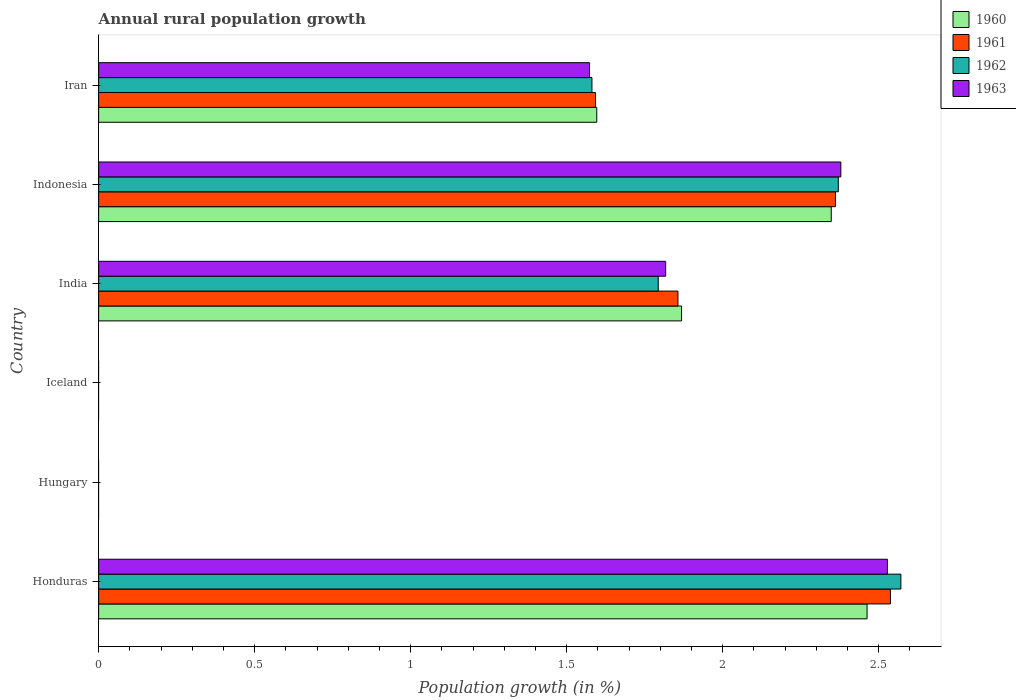Are the number of bars on each tick of the Y-axis equal?
Offer a very short reply. No. How many bars are there on the 6th tick from the bottom?
Make the answer very short. 4. What is the label of the 1st group of bars from the top?
Ensure brevity in your answer.  Iran. In how many cases, is the number of bars for a given country not equal to the number of legend labels?
Your answer should be compact. 2. What is the percentage of rural population growth in 1963 in Honduras?
Ensure brevity in your answer.  2.53. Across all countries, what is the maximum percentage of rural population growth in 1961?
Give a very brief answer. 2.54. In which country was the percentage of rural population growth in 1963 maximum?
Provide a succinct answer. Honduras. What is the total percentage of rural population growth in 1960 in the graph?
Provide a succinct answer. 8.28. What is the difference between the percentage of rural population growth in 1960 in Indonesia and that in Iran?
Provide a short and direct response. 0.75. What is the difference between the percentage of rural population growth in 1960 in India and the percentage of rural population growth in 1961 in Iran?
Provide a succinct answer. 0.28. What is the average percentage of rural population growth in 1963 per country?
Keep it short and to the point. 1.38. What is the difference between the percentage of rural population growth in 1961 and percentage of rural population growth in 1963 in Honduras?
Make the answer very short. 0.01. In how many countries, is the percentage of rural population growth in 1963 greater than 1.5 %?
Your response must be concise. 4. What is the ratio of the percentage of rural population growth in 1960 in Honduras to that in India?
Offer a terse response. 1.32. What is the difference between the highest and the second highest percentage of rural population growth in 1962?
Keep it short and to the point. 0.2. What is the difference between the highest and the lowest percentage of rural population growth in 1961?
Make the answer very short. 2.54. In how many countries, is the percentage of rural population growth in 1961 greater than the average percentage of rural population growth in 1961 taken over all countries?
Make the answer very short. 4. Is it the case that in every country, the sum of the percentage of rural population growth in 1962 and percentage of rural population growth in 1963 is greater than the sum of percentage of rural population growth in 1960 and percentage of rural population growth in 1961?
Ensure brevity in your answer.  No. Is it the case that in every country, the sum of the percentage of rural population growth in 1962 and percentage of rural population growth in 1960 is greater than the percentage of rural population growth in 1963?
Keep it short and to the point. No. How many countries are there in the graph?
Your response must be concise. 6. What is the difference between two consecutive major ticks on the X-axis?
Your answer should be very brief. 0.5. Does the graph contain any zero values?
Provide a succinct answer. Yes. Does the graph contain grids?
Provide a succinct answer. No. Where does the legend appear in the graph?
Give a very brief answer. Top right. How many legend labels are there?
Give a very brief answer. 4. What is the title of the graph?
Keep it short and to the point. Annual rural population growth. Does "1970" appear as one of the legend labels in the graph?
Provide a succinct answer. No. What is the label or title of the X-axis?
Your answer should be very brief. Population growth (in %). What is the label or title of the Y-axis?
Your response must be concise. Country. What is the Population growth (in %) in 1960 in Honduras?
Your response must be concise. 2.46. What is the Population growth (in %) of 1961 in Honduras?
Make the answer very short. 2.54. What is the Population growth (in %) of 1962 in Honduras?
Provide a succinct answer. 2.57. What is the Population growth (in %) of 1963 in Honduras?
Give a very brief answer. 2.53. What is the Population growth (in %) of 1961 in Hungary?
Offer a very short reply. 0. What is the Population growth (in %) of 1962 in Hungary?
Make the answer very short. 0. What is the Population growth (in %) of 1960 in Iceland?
Keep it short and to the point. 0. What is the Population growth (in %) in 1963 in Iceland?
Provide a succinct answer. 0. What is the Population growth (in %) in 1960 in India?
Your response must be concise. 1.87. What is the Population growth (in %) in 1961 in India?
Ensure brevity in your answer.  1.86. What is the Population growth (in %) in 1962 in India?
Offer a very short reply. 1.79. What is the Population growth (in %) in 1963 in India?
Keep it short and to the point. 1.82. What is the Population growth (in %) of 1960 in Indonesia?
Your answer should be very brief. 2.35. What is the Population growth (in %) of 1961 in Indonesia?
Make the answer very short. 2.36. What is the Population growth (in %) in 1962 in Indonesia?
Provide a short and direct response. 2.37. What is the Population growth (in %) of 1963 in Indonesia?
Your response must be concise. 2.38. What is the Population growth (in %) in 1960 in Iran?
Offer a very short reply. 1.6. What is the Population growth (in %) of 1961 in Iran?
Give a very brief answer. 1.59. What is the Population growth (in %) in 1962 in Iran?
Provide a short and direct response. 1.58. What is the Population growth (in %) of 1963 in Iran?
Provide a short and direct response. 1.57. Across all countries, what is the maximum Population growth (in %) in 1960?
Provide a succinct answer. 2.46. Across all countries, what is the maximum Population growth (in %) of 1961?
Make the answer very short. 2.54. Across all countries, what is the maximum Population growth (in %) of 1962?
Keep it short and to the point. 2.57. Across all countries, what is the maximum Population growth (in %) of 1963?
Offer a terse response. 2.53. Across all countries, what is the minimum Population growth (in %) of 1961?
Your answer should be very brief. 0. What is the total Population growth (in %) in 1960 in the graph?
Your answer should be compact. 8.28. What is the total Population growth (in %) in 1961 in the graph?
Offer a terse response. 8.35. What is the total Population growth (in %) of 1962 in the graph?
Keep it short and to the point. 8.32. What is the total Population growth (in %) of 1963 in the graph?
Make the answer very short. 8.3. What is the difference between the Population growth (in %) of 1960 in Honduras and that in India?
Provide a short and direct response. 0.59. What is the difference between the Population growth (in %) of 1961 in Honduras and that in India?
Your response must be concise. 0.68. What is the difference between the Population growth (in %) of 1962 in Honduras and that in India?
Provide a short and direct response. 0.78. What is the difference between the Population growth (in %) in 1963 in Honduras and that in India?
Offer a very short reply. 0.71. What is the difference between the Population growth (in %) in 1960 in Honduras and that in Indonesia?
Provide a succinct answer. 0.11. What is the difference between the Population growth (in %) of 1961 in Honduras and that in Indonesia?
Your response must be concise. 0.18. What is the difference between the Population growth (in %) in 1962 in Honduras and that in Indonesia?
Your answer should be compact. 0.2. What is the difference between the Population growth (in %) of 1963 in Honduras and that in Indonesia?
Provide a short and direct response. 0.15. What is the difference between the Population growth (in %) of 1960 in Honduras and that in Iran?
Provide a succinct answer. 0.87. What is the difference between the Population growth (in %) in 1961 in Honduras and that in Iran?
Give a very brief answer. 0.95. What is the difference between the Population growth (in %) of 1962 in Honduras and that in Iran?
Your answer should be compact. 0.99. What is the difference between the Population growth (in %) of 1963 in Honduras and that in Iran?
Keep it short and to the point. 0.95. What is the difference between the Population growth (in %) of 1960 in India and that in Indonesia?
Offer a terse response. -0.48. What is the difference between the Population growth (in %) of 1961 in India and that in Indonesia?
Your answer should be compact. -0.5. What is the difference between the Population growth (in %) of 1962 in India and that in Indonesia?
Provide a short and direct response. -0.58. What is the difference between the Population growth (in %) of 1963 in India and that in Indonesia?
Give a very brief answer. -0.56. What is the difference between the Population growth (in %) in 1960 in India and that in Iran?
Give a very brief answer. 0.27. What is the difference between the Population growth (in %) in 1961 in India and that in Iran?
Make the answer very short. 0.26. What is the difference between the Population growth (in %) in 1962 in India and that in Iran?
Provide a short and direct response. 0.21. What is the difference between the Population growth (in %) in 1963 in India and that in Iran?
Make the answer very short. 0.24. What is the difference between the Population growth (in %) of 1960 in Indonesia and that in Iran?
Your response must be concise. 0.75. What is the difference between the Population growth (in %) in 1961 in Indonesia and that in Iran?
Provide a short and direct response. 0.77. What is the difference between the Population growth (in %) in 1962 in Indonesia and that in Iran?
Offer a terse response. 0.79. What is the difference between the Population growth (in %) in 1963 in Indonesia and that in Iran?
Offer a very short reply. 0.81. What is the difference between the Population growth (in %) in 1960 in Honduras and the Population growth (in %) in 1961 in India?
Offer a very short reply. 0.61. What is the difference between the Population growth (in %) of 1960 in Honduras and the Population growth (in %) of 1962 in India?
Offer a very short reply. 0.67. What is the difference between the Population growth (in %) of 1960 in Honduras and the Population growth (in %) of 1963 in India?
Your answer should be very brief. 0.65. What is the difference between the Population growth (in %) of 1961 in Honduras and the Population growth (in %) of 1962 in India?
Keep it short and to the point. 0.74. What is the difference between the Population growth (in %) in 1961 in Honduras and the Population growth (in %) in 1963 in India?
Give a very brief answer. 0.72. What is the difference between the Population growth (in %) of 1962 in Honduras and the Population growth (in %) of 1963 in India?
Provide a short and direct response. 0.75. What is the difference between the Population growth (in %) in 1960 in Honduras and the Population growth (in %) in 1961 in Indonesia?
Keep it short and to the point. 0.1. What is the difference between the Population growth (in %) of 1960 in Honduras and the Population growth (in %) of 1962 in Indonesia?
Ensure brevity in your answer.  0.09. What is the difference between the Population growth (in %) in 1960 in Honduras and the Population growth (in %) in 1963 in Indonesia?
Your answer should be compact. 0.08. What is the difference between the Population growth (in %) in 1961 in Honduras and the Population growth (in %) in 1962 in Indonesia?
Offer a very short reply. 0.17. What is the difference between the Population growth (in %) in 1961 in Honduras and the Population growth (in %) in 1963 in Indonesia?
Make the answer very short. 0.16. What is the difference between the Population growth (in %) of 1962 in Honduras and the Population growth (in %) of 1963 in Indonesia?
Keep it short and to the point. 0.19. What is the difference between the Population growth (in %) of 1960 in Honduras and the Population growth (in %) of 1961 in Iran?
Make the answer very short. 0.87. What is the difference between the Population growth (in %) of 1960 in Honduras and the Population growth (in %) of 1962 in Iran?
Your answer should be compact. 0.88. What is the difference between the Population growth (in %) in 1960 in Honduras and the Population growth (in %) in 1963 in Iran?
Your answer should be very brief. 0.89. What is the difference between the Population growth (in %) in 1961 in Honduras and the Population growth (in %) in 1962 in Iran?
Your answer should be compact. 0.96. What is the difference between the Population growth (in %) of 1961 in Honduras and the Population growth (in %) of 1963 in Iran?
Your answer should be compact. 0.96. What is the difference between the Population growth (in %) in 1960 in India and the Population growth (in %) in 1961 in Indonesia?
Offer a terse response. -0.49. What is the difference between the Population growth (in %) of 1960 in India and the Population growth (in %) of 1962 in Indonesia?
Offer a terse response. -0.5. What is the difference between the Population growth (in %) in 1960 in India and the Population growth (in %) in 1963 in Indonesia?
Your answer should be compact. -0.51. What is the difference between the Population growth (in %) of 1961 in India and the Population growth (in %) of 1962 in Indonesia?
Your answer should be compact. -0.51. What is the difference between the Population growth (in %) in 1961 in India and the Population growth (in %) in 1963 in Indonesia?
Offer a terse response. -0.52. What is the difference between the Population growth (in %) of 1962 in India and the Population growth (in %) of 1963 in Indonesia?
Offer a terse response. -0.59. What is the difference between the Population growth (in %) of 1960 in India and the Population growth (in %) of 1961 in Iran?
Offer a very short reply. 0.28. What is the difference between the Population growth (in %) in 1960 in India and the Population growth (in %) in 1962 in Iran?
Provide a short and direct response. 0.29. What is the difference between the Population growth (in %) in 1960 in India and the Population growth (in %) in 1963 in Iran?
Ensure brevity in your answer.  0.29. What is the difference between the Population growth (in %) in 1961 in India and the Population growth (in %) in 1962 in Iran?
Your answer should be compact. 0.28. What is the difference between the Population growth (in %) in 1961 in India and the Population growth (in %) in 1963 in Iran?
Offer a very short reply. 0.28. What is the difference between the Population growth (in %) in 1962 in India and the Population growth (in %) in 1963 in Iran?
Provide a succinct answer. 0.22. What is the difference between the Population growth (in %) in 1960 in Indonesia and the Population growth (in %) in 1961 in Iran?
Ensure brevity in your answer.  0.76. What is the difference between the Population growth (in %) in 1960 in Indonesia and the Population growth (in %) in 1962 in Iran?
Give a very brief answer. 0.77. What is the difference between the Population growth (in %) of 1960 in Indonesia and the Population growth (in %) of 1963 in Iran?
Keep it short and to the point. 0.77. What is the difference between the Population growth (in %) in 1961 in Indonesia and the Population growth (in %) in 1962 in Iran?
Ensure brevity in your answer.  0.78. What is the difference between the Population growth (in %) in 1961 in Indonesia and the Population growth (in %) in 1963 in Iran?
Make the answer very short. 0.79. What is the difference between the Population growth (in %) of 1962 in Indonesia and the Population growth (in %) of 1963 in Iran?
Offer a terse response. 0.8. What is the average Population growth (in %) of 1960 per country?
Keep it short and to the point. 1.38. What is the average Population growth (in %) in 1961 per country?
Your response must be concise. 1.39. What is the average Population growth (in %) in 1962 per country?
Your answer should be compact. 1.39. What is the average Population growth (in %) of 1963 per country?
Your answer should be compact. 1.38. What is the difference between the Population growth (in %) in 1960 and Population growth (in %) in 1961 in Honduras?
Your answer should be very brief. -0.07. What is the difference between the Population growth (in %) of 1960 and Population growth (in %) of 1962 in Honduras?
Offer a very short reply. -0.11. What is the difference between the Population growth (in %) in 1960 and Population growth (in %) in 1963 in Honduras?
Make the answer very short. -0.07. What is the difference between the Population growth (in %) of 1961 and Population growth (in %) of 1962 in Honduras?
Your answer should be compact. -0.03. What is the difference between the Population growth (in %) in 1961 and Population growth (in %) in 1963 in Honduras?
Offer a terse response. 0.01. What is the difference between the Population growth (in %) in 1962 and Population growth (in %) in 1963 in Honduras?
Make the answer very short. 0.04. What is the difference between the Population growth (in %) of 1960 and Population growth (in %) of 1961 in India?
Ensure brevity in your answer.  0.01. What is the difference between the Population growth (in %) of 1960 and Population growth (in %) of 1962 in India?
Your answer should be compact. 0.07. What is the difference between the Population growth (in %) in 1960 and Population growth (in %) in 1963 in India?
Offer a terse response. 0.05. What is the difference between the Population growth (in %) in 1961 and Population growth (in %) in 1962 in India?
Your answer should be compact. 0.06. What is the difference between the Population growth (in %) of 1961 and Population growth (in %) of 1963 in India?
Ensure brevity in your answer.  0.04. What is the difference between the Population growth (in %) of 1962 and Population growth (in %) of 1963 in India?
Provide a short and direct response. -0.02. What is the difference between the Population growth (in %) of 1960 and Population growth (in %) of 1961 in Indonesia?
Your response must be concise. -0.01. What is the difference between the Population growth (in %) of 1960 and Population growth (in %) of 1962 in Indonesia?
Make the answer very short. -0.02. What is the difference between the Population growth (in %) in 1960 and Population growth (in %) in 1963 in Indonesia?
Your answer should be compact. -0.03. What is the difference between the Population growth (in %) in 1961 and Population growth (in %) in 1962 in Indonesia?
Provide a succinct answer. -0.01. What is the difference between the Population growth (in %) of 1961 and Population growth (in %) of 1963 in Indonesia?
Give a very brief answer. -0.02. What is the difference between the Population growth (in %) in 1962 and Population growth (in %) in 1963 in Indonesia?
Your response must be concise. -0.01. What is the difference between the Population growth (in %) of 1960 and Population growth (in %) of 1961 in Iran?
Ensure brevity in your answer.  0. What is the difference between the Population growth (in %) in 1960 and Population growth (in %) in 1962 in Iran?
Ensure brevity in your answer.  0.02. What is the difference between the Population growth (in %) in 1960 and Population growth (in %) in 1963 in Iran?
Ensure brevity in your answer.  0.02. What is the difference between the Population growth (in %) in 1961 and Population growth (in %) in 1962 in Iran?
Offer a terse response. 0.01. What is the difference between the Population growth (in %) in 1961 and Population growth (in %) in 1963 in Iran?
Make the answer very short. 0.02. What is the difference between the Population growth (in %) in 1962 and Population growth (in %) in 1963 in Iran?
Offer a very short reply. 0.01. What is the ratio of the Population growth (in %) of 1960 in Honduras to that in India?
Provide a short and direct response. 1.32. What is the ratio of the Population growth (in %) of 1961 in Honduras to that in India?
Offer a very short reply. 1.37. What is the ratio of the Population growth (in %) in 1962 in Honduras to that in India?
Your response must be concise. 1.43. What is the ratio of the Population growth (in %) in 1963 in Honduras to that in India?
Provide a short and direct response. 1.39. What is the ratio of the Population growth (in %) of 1960 in Honduras to that in Indonesia?
Your answer should be compact. 1.05. What is the ratio of the Population growth (in %) in 1961 in Honduras to that in Indonesia?
Make the answer very short. 1.07. What is the ratio of the Population growth (in %) of 1962 in Honduras to that in Indonesia?
Make the answer very short. 1.08. What is the ratio of the Population growth (in %) of 1963 in Honduras to that in Indonesia?
Keep it short and to the point. 1.06. What is the ratio of the Population growth (in %) of 1960 in Honduras to that in Iran?
Give a very brief answer. 1.54. What is the ratio of the Population growth (in %) of 1961 in Honduras to that in Iran?
Offer a terse response. 1.59. What is the ratio of the Population growth (in %) of 1962 in Honduras to that in Iran?
Give a very brief answer. 1.63. What is the ratio of the Population growth (in %) of 1963 in Honduras to that in Iran?
Offer a terse response. 1.61. What is the ratio of the Population growth (in %) in 1960 in India to that in Indonesia?
Your answer should be compact. 0.8. What is the ratio of the Population growth (in %) of 1961 in India to that in Indonesia?
Your answer should be compact. 0.79. What is the ratio of the Population growth (in %) in 1962 in India to that in Indonesia?
Provide a short and direct response. 0.76. What is the ratio of the Population growth (in %) in 1963 in India to that in Indonesia?
Offer a very short reply. 0.76. What is the ratio of the Population growth (in %) of 1960 in India to that in Iran?
Provide a short and direct response. 1.17. What is the ratio of the Population growth (in %) of 1961 in India to that in Iran?
Ensure brevity in your answer.  1.17. What is the ratio of the Population growth (in %) of 1962 in India to that in Iran?
Give a very brief answer. 1.13. What is the ratio of the Population growth (in %) of 1963 in India to that in Iran?
Your response must be concise. 1.16. What is the ratio of the Population growth (in %) in 1960 in Indonesia to that in Iran?
Give a very brief answer. 1.47. What is the ratio of the Population growth (in %) in 1961 in Indonesia to that in Iran?
Ensure brevity in your answer.  1.48. What is the ratio of the Population growth (in %) of 1962 in Indonesia to that in Iran?
Keep it short and to the point. 1.5. What is the ratio of the Population growth (in %) in 1963 in Indonesia to that in Iran?
Offer a very short reply. 1.51. What is the difference between the highest and the second highest Population growth (in %) in 1960?
Provide a short and direct response. 0.11. What is the difference between the highest and the second highest Population growth (in %) of 1961?
Make the answer very short. 0.18. What is the difference between the highest and the second highest Population growth (in %) in 1962?
Offer a very short reply. 0.2. What is the difference between the highest and the second highest Population growth (in %) in 1963?
Your response must be concise. 0.15. What is the difference between the highest and the lowest Population growth (in %) of 1960?
Provide a succinct answer. 2.46. What is the difference between the highest and the lowest Population growth (in %) in 1961?
Ensure brevity in your answer.  2.54. What is the difference between the highest and the lowest Population growth (in %) of 1962?
Offer a terse response. 2.57. What is the difference between the highest and the lowest Population growth (in %) in 1963?
Your response must be concise. 2.53. 